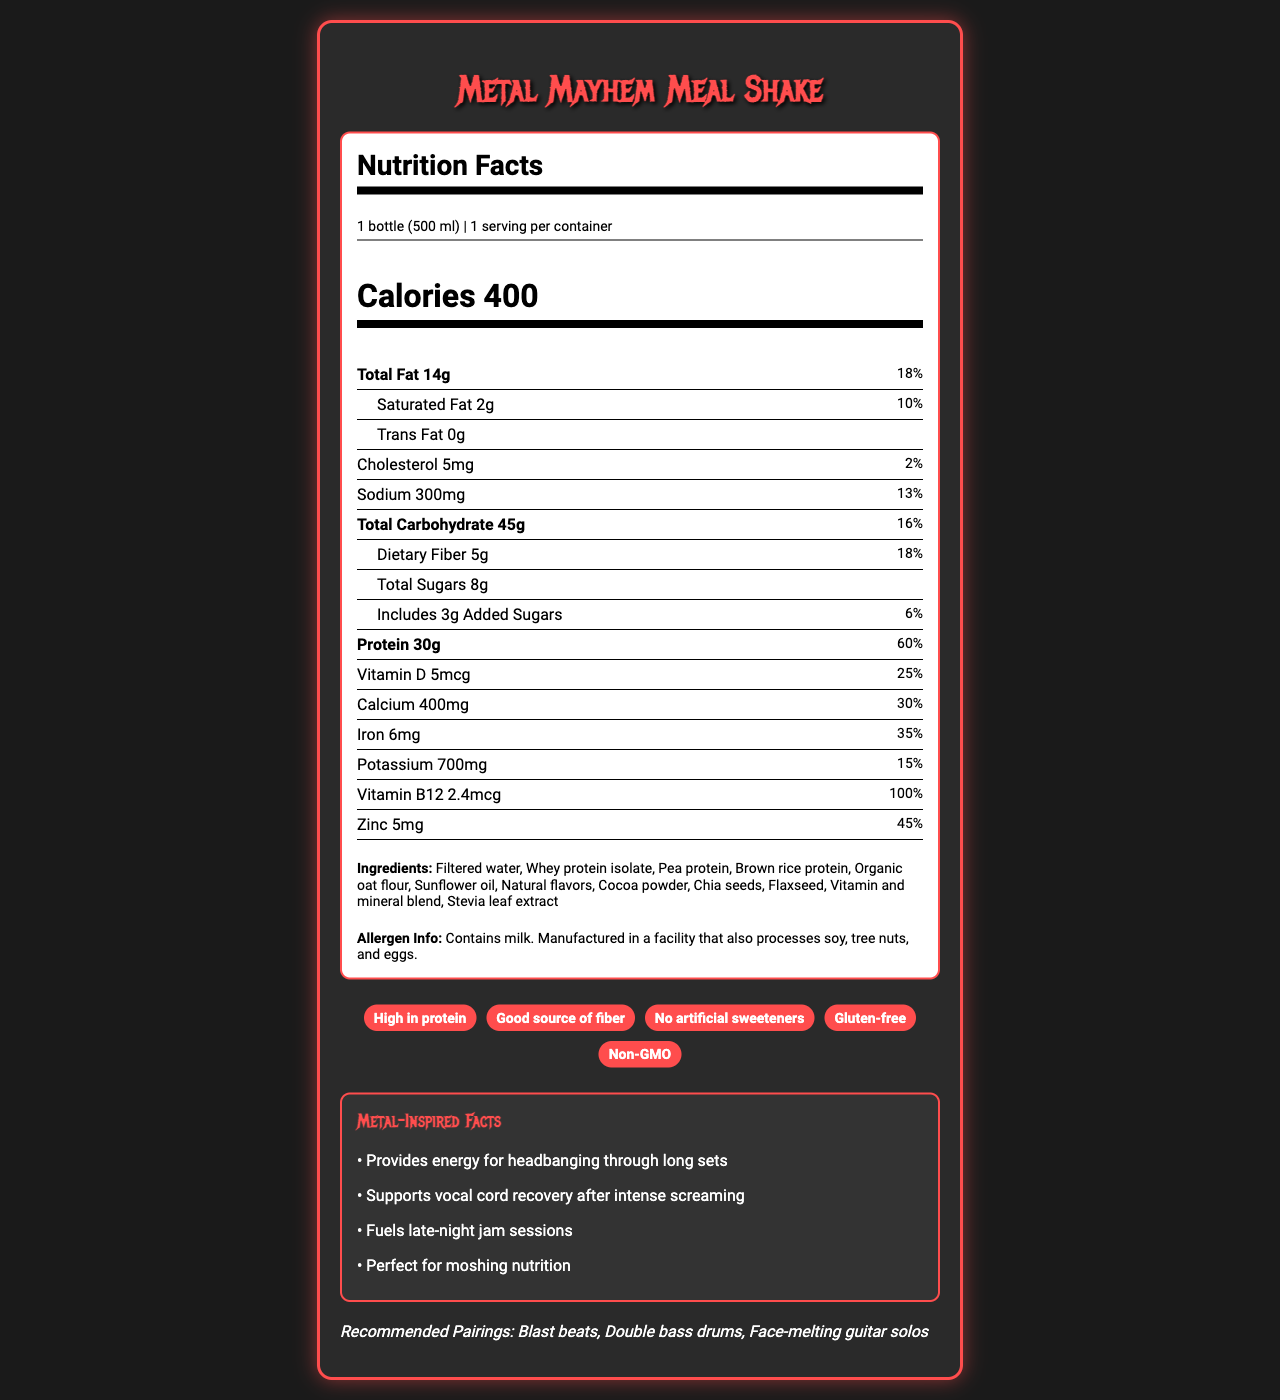what is the serving size of the Metal Mayhem Meal Shake? The serving size is listed in the serving information section of the nutrition label and it says "1 bottle (500 ml)".
Answer: 1 bottle (500 ml) how many calories does the Metal Mayhem Meal Shake contain? The calories are prominently displayed in large font within the nutrition label, stating "Calories 400".
Answer: 400 what is the primary source of protein in the Metal Mayhem Meal Shake? The ingredients list shows whey protein isolate as the first ingredient, indicating it is the primary source of protein.
Answer: Whey protein isolate how much protein is in one bottle of Metal Mayhem Meal Shake? The amount of protein is displayed in the bold section of the nutrition label indicating "Protein 30g".
Answer: 30g list three vitamins or minerals found in the Metal Mayhem Meal Shake The nutrition label lists various vitamins and minerals and their amounts, including Vitamin D (5mcg), Calcium (400mg), and Iron (6mg).
Answer: Vitamin D, Calcium, Iron how much dietary fiber does the Metal Mayhem Meal Shake include? A. 3g B. 2g C. 5g D. 8g The amount of dietary fiber is displayed as "Dietary Fiber 5g" in the total carbohydrate section of the nutrition label.
Answer: C. 5g which of the following is NOT a claim made about the Metal Mayhem Meal Shake? A. High in protein B. Contains artificial sweeteners C. Gluten-free D. Non-GMO The product claims section includes "High in protein", "Gluten-free", and "Non-GMO" but states "No artificial sweeteners", meaning it does not contain artificial sweeteners.
Answer: B. Contains artificial sweeteners is this meal shake suitable for people with soy allergies? The allergen info states that the product is manufactured in a facility that also processes soy.
Answer: No summarize the main features of the Metal Mayhem Meal Shake from the document. The key features include nutritional information, benefits targeted for musicians, and product claims. It details serving size, calories, fat, protein, vitamins, and mineral content, plus allergen and ingredient information.
Answer: The Metal Mayhem Meal Shake is a 500 ml, 400-calorie meal replacement designed for musicians. It contains 30g of protein and a variety of vitamins and minerals. It is high in protein, gluten-free, non-GMO, and contains no artificial sweeteners. It includes milk and is processed in a facility with soy, tree nuts, and eggs. The shake supports energy for performances and recovery. what is the amount of added sugars in the Metal Mayhem Meal Shake? The nutrition label indicates "Includes 3g Added Sugars" in the total carbohydrate section.
Answer: 3g does the Metal Mayhem Meal Shake contain trans fat? The nutrition label specifically states "Trans Fat 0g".
Answer: No what energy benefits does the Metal Mayhem Meal Shake claim to provide? The metal-inspired facts section lists these energy benefits.
Answer: Provides energy for headbanging through long sets, supports vocal cord recovery after intense screaming, fuels late-night jam sessions, perfect for moshing nutrition what pairs well with the Metal Mayhem Meal Shake according to the document? The recommended pairings section lists these musical elements.
Answer: Blast beats, Double bass drums, Face-melting guitar solos which ingredient is NOT listed in the Metal Mayhem Meal Shake? A. Chia seeds B. Brown rice protein C. Soy protein D. Flaxseed The ingredients list includes chia seeds, brown rice protein, and flaxseed but does not mention soy protein.
Answer: C. Soy protein is this meal shake high in saturated fat? The nutrition label shows that the shake contains 2g of saturated fat, which is 10% of the daily value, not high enough to be considered high in saturated fat.
Answer: No what is the total sugar content of the Metal Mayhem Meal Shake? The total sugara content is shown as "Total Sugars 8g" in the nutrition label.
Answer: 8g who is the intended consumer for this product based on the document? The document and product name suggest that the Metal Mayhem Meal Shake is designed for touring musicians, supported by the claims about energy for long sets and recovery after performances.
Answer: Touring musicians what is the daily value percentage of Iron in this meal shake? The nutrition label indicates that the meal shake contains 6mg of Iron, which is 35% of the daily value.
Answer: 35% explain the taste and flavor components of this meal shake? The document does not provide any specific information about the taste and flavor components of the meal shake, only listing natural flavors and cocoa powder as ingredients.
Answer: Cannot be determined 